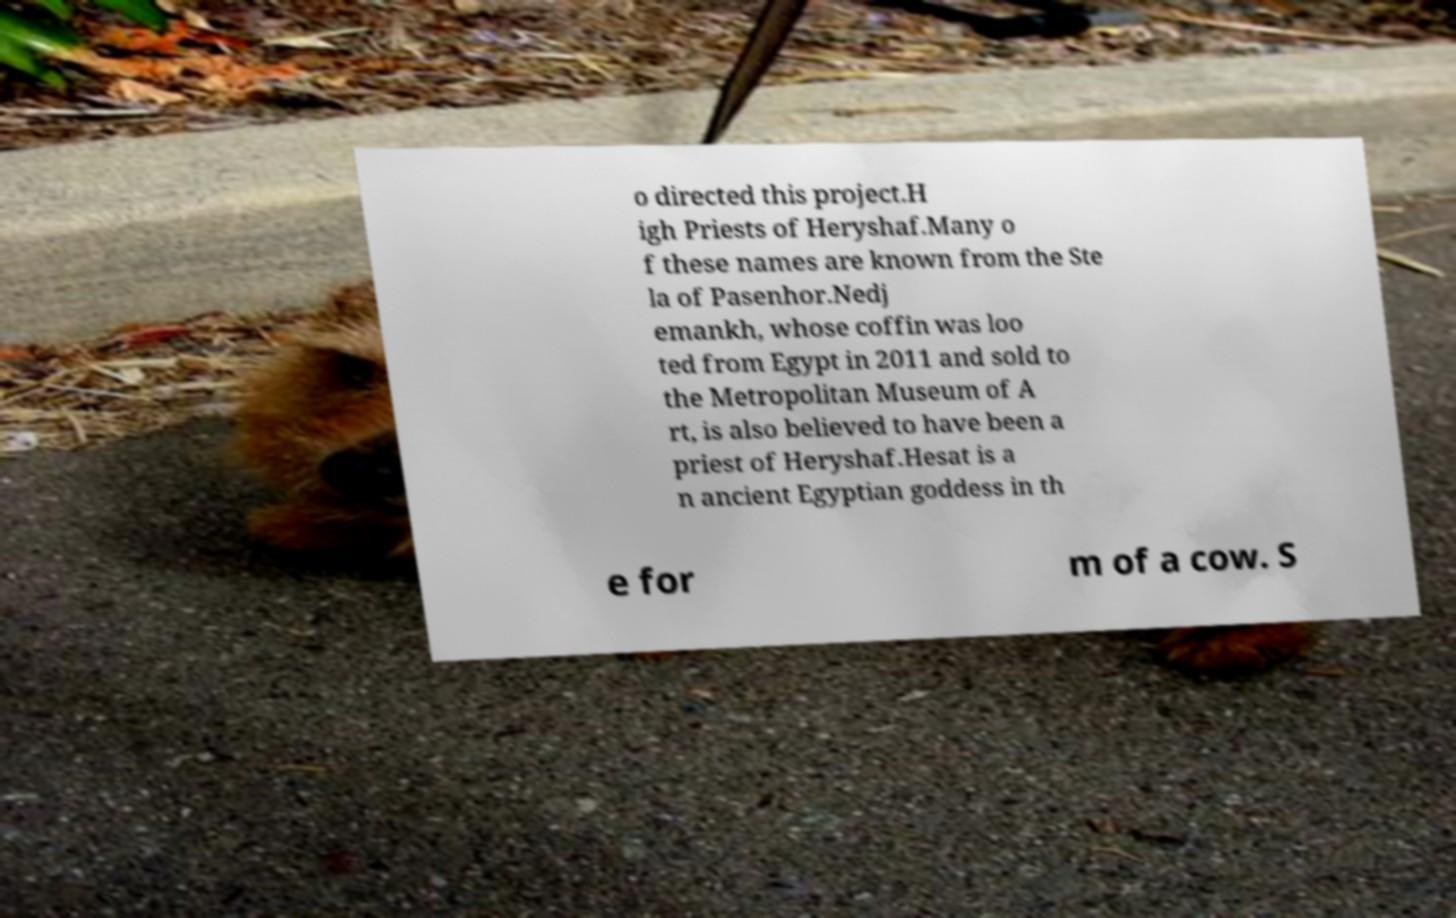What messages or text are displayed in this image? I need them in a readable, typed format. o directed this project.H igh Priests of Heryshaf.Many o f these names are known from the Ste la of Pasenhor.Nedj emankh, whose coffin was loo ted from Egypt in 2011 and sold to the Metropolitan Museum of A rt, is also believed to have been a priest of Heryshaf.Hesat is a n ancient Egyptian goddess in th e for m of a cow. S 